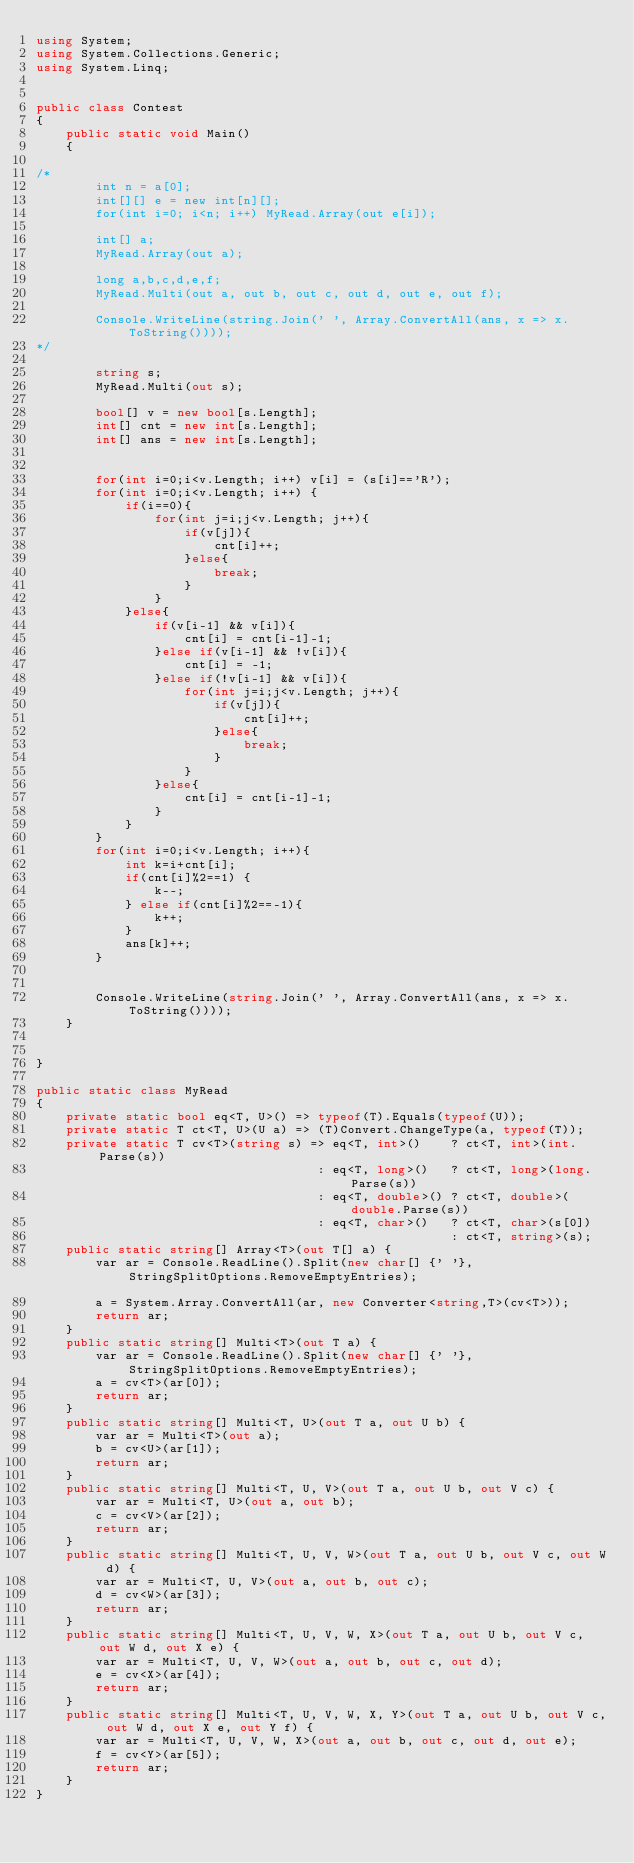Convert code to text. <code><loc_0><loc_0><loc_500><loc_500><_C#_>using System;
using System.Collections.Generic;
using System.Linq;


public class Contest
{
	public static void Main()
	{

/*
		int n = a[0];
		int[][] e = new int[n][];
		for(int i=0; i<n; i++) MyRead.Array(out e[i]);

		int[] a;
		MyRead.Array(out a);

        long a,b,c,d,e,f;
        MyRead.Multi(out a, out b, out c, out d, out e, out f);

		Console.WriteLine(string.Join(' ', Array.ConvertAll(ans, x => x.ToString())));
*/

        string s;
		MyRead.Multi(out s);

		bool[] v = new bool[s.Length];
		int[] cnt = new int[s.Length];
		int[] ans = new int[s.Length];


		for(int i=0;i<v.Length; i++) v[i] = (s[i]=='R');
		for(int i=0;i<v.Length; i++) {
			if(i==0){
				for(int j=i;j<v.Length; j++){
					if(v[j]){
						cnt[i]++;
					}else{
						break;
					}
				}
			}else{
				if(v[i-1] && v[i]){
					cnt[i] = cnt[i-1]-1;
				}else if(v[i-1] && !v[i]){
					cnt[i] = -1;
				}else if(!v[i-1] && v[i]){
					for(int j=i;j<v.Length; j++){
						if(v[j]){
							cnt[i]++;
						}else{
							break;
						}
					}
				}else{
					cnt[i] = cnt[i-1]-1;
				}
			}
		}
		for(int i=0;i<v.Length; i++){
			int k=i+cnt[i];
			if(cnt[i]%2==1) {
				k--;
			} else if(cnt[i]%2==-1){
				k++;
			}
			ans[k]++;
		}


		Console.WriteLine(string.Join(' ', Array.ConvertAll(ans, x => x.ToString())));
	}


}

public static class MyRead
{
	private static bool eq<T, U>() => typeof(T).Equals(typeof(U));
	private static T ct<T, U>(U a) => (T)Convert.ChangeType(a, typeof(T));
	private static T cv<T>(string s) => eq<T, int>()    ? ct<T, int>(int.Parse(s))
	                                  : eq<T, long>()   ? ct<T, long>(long.Parse(s))
	                                  : eq<T, double>() ? ct<T, double>(double.Parse(s))
	                                  : eq<T, char>()   ? ct<T, char>(s[0])
	                                                    : ct<T, string>(s);
	public static string[] Array<T>(out T[] a) {		
		var ar = Console.ReadLine().Split(new char[] {' '}, StringSplitOptions.RemoveEmptyEntries); 												
		a = System.Array.ConvertAll(ar, new Converter<string,T>(cv<T>));
		return ar;
	}										
	public static string[] Multi<T>(out T a) {
		var ar = Console.ReadLine().Split(new char[] {' '}, StringSplitOptions.RemoveEmptyEntries); 
		a = cv<T>(ar[0]);
		return ar;
	}
	public static string[] Multi<T, U>(out T a, out U b) {
		var ar = Multi<T>(out a); 
        b = cv<U>(ar[1]);
		return ar;
	}
	public static string[] Multi<T, U, V>(out T a, out U b, out V c) {
		var ar = Multi<T, U>(out a, out b); 
        c = cv<V>(ar[2]);
		return ar;
	}
	public static string[] Multi<T, U, V, W>(out T a, out U b, out V c, out W d) {
		var ar = Multi<T, U, V>(out a, out b, out c); 
        d = cv<W>(ar[3]);
		return ar;
	}
	public static string[] Multi<T, U, V, W, X>(out T a, out U b, out V c, out W d, out X e) {
		var ar = Multi<T, U, V, W>(out a, out b, out c, out d); 
        e = cv<X>(ar[4]);
		return ar;
	}
	public static string[] Multi<T, U, V, W, X, Y>(out T a, out U b, out V c, out W d, out X e, out Y f) {
		var ar = Multi<T, U, V, W, X>(out a, out b, out c, out d, out e); 
        f = cv<Y>(ar[5]);
		return ar;
	}
}


</code> 